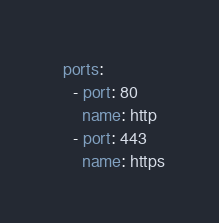Convert code to text. <code><loc_0><loc_0><loc_500><loc_500><_YAML_>  ports:
    - port: 80
      name: http
    - port: 443
      name: https</code> 